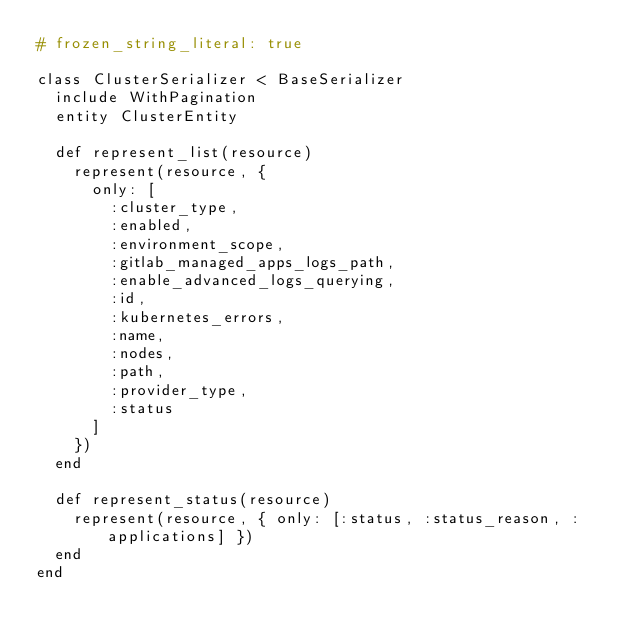Convert code to text. <code><loc_0><loc_0><loc_500><loc_500><_Ruby_># frozen_string_literal: true

class ClusterSerializer < BaseSerializer
  include WithPagination
  entity ClusterEntity

  def represent_list(resource)
    represent(resource, {
      only: [
        :cluster_type,
        :enabled,
        :environment_scope,
        :gitlab_managed_apps_logs_path,
        :enable_advanced_logs_querying,
        :id,
        :kubernetes_errors,
        :name,
        :nodes,
        :path,
        :provider_type,
        :status
      ]
    })
  end

  def represent_status(resource)
    represent(resource, { only: [:status, :status_reason, :applications] })
  end
end
</code> 